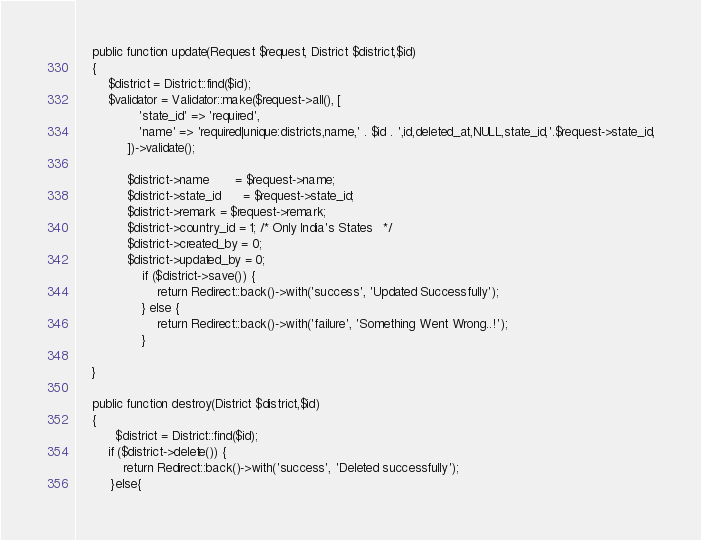Convert code to text. <code><loc_0><loc_0><loc_500><loc_500><_PHP_>
    public function update(Request $request, District $district,$id)
    {
        $district = District::find($id);
        $validator = Validator::make($request->all(), [
                'state_id' => 'required',
                'name' => 'required|unique:districts,name,' . $id . ',id,deleted_at,NULL,state_id,'.$request->state_id,
             ])->validate();

             $district->name       = $request->name;
             $district->state_id      = $request->state_id;
             $district->remark = $request->remark;
             $district->country_id = 1; /* Only India's States   */
             $district->created_by = 0;
             $district->updated_by = 0;
                 if ($district->save()) {
                     return Redirect::back()->with('success', 'Updated Successfully');
                 } else {
                     return Redirect::back()->with('failure', 'Something Went Wrong..!');
                 }
        
    }

    public function destroy(District $district,$id)
    {
          $district = District::find($id);
        if ($district->delete()) {
            return Redirect::back()->with('success', 'Deleted successfully');
         }else{</code> 